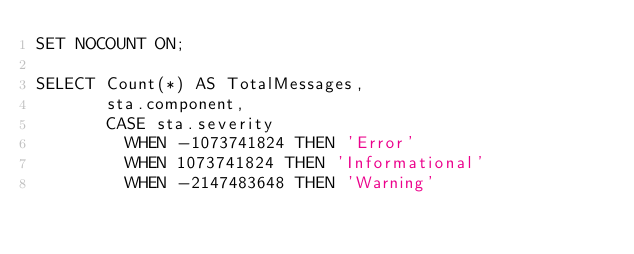Convert code to text. <code><loc_0><loc_0><loc_500><loc_500><_SQL_>SET NOCOUNT ON;

SELECT Count(*) AS TotalMessages,
       sta.component,
       CASE sta.severity
         WHEN -1073741824 THEN 'Error'
         WHEN 1073741824 THEN 'Informational'
         WHEN -2147483648 THEN 'Warning'</code> 